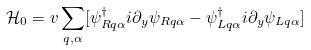<formula> <loc_0><loc_0><loc_500><loc_500>\mathcal { H } _ { 0 } = v \sum _ { q , \alpha } [ \psi ^ { \dag } _ { R q \alpha } i \partial _ { y } \psi _ { R q \alpha } - \psi ^ { \dag } _ { L q \alpha } i \partial _ { y } \psi _ { L q \alpha } ]</formula> 